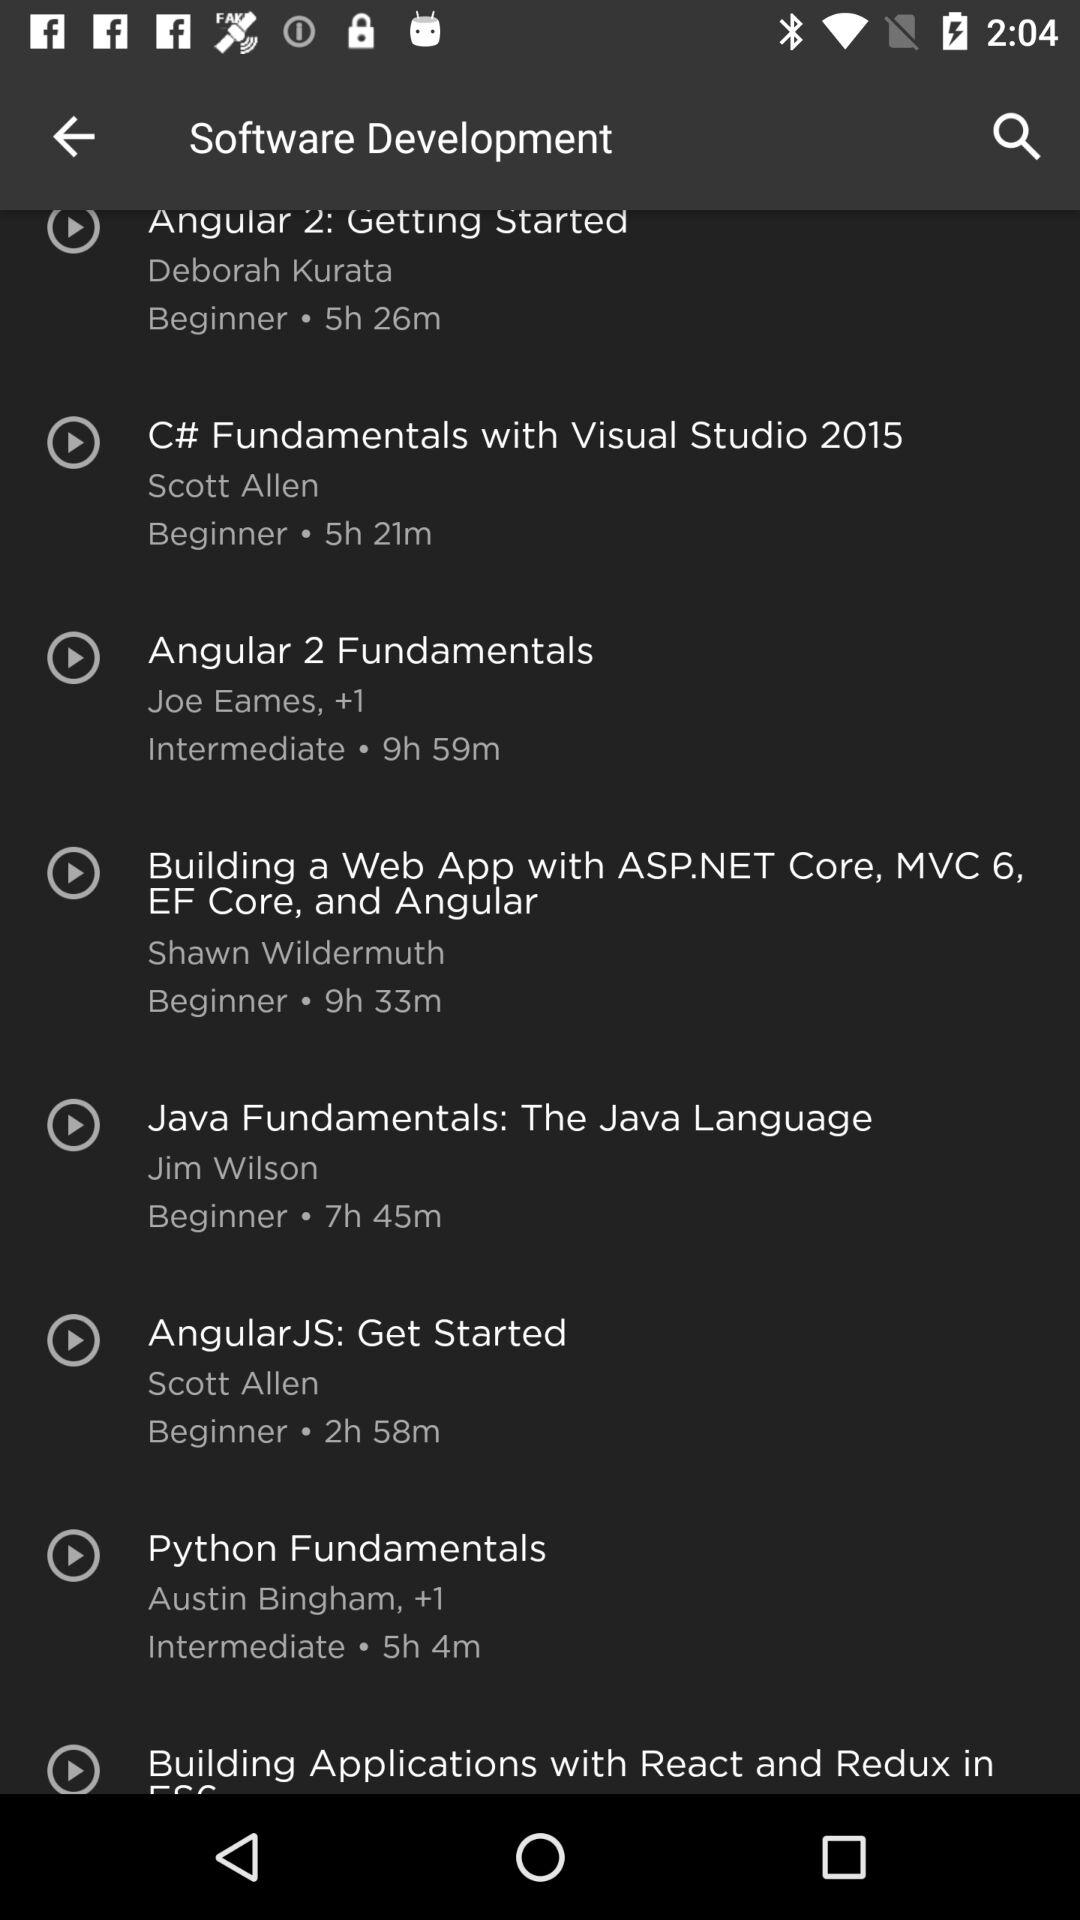Who is the creator of "C# Fundamentals with Visual Studio 2015"? The creator of "C# Fundamentals with Visual Studio 2015" is Scott Allen. 